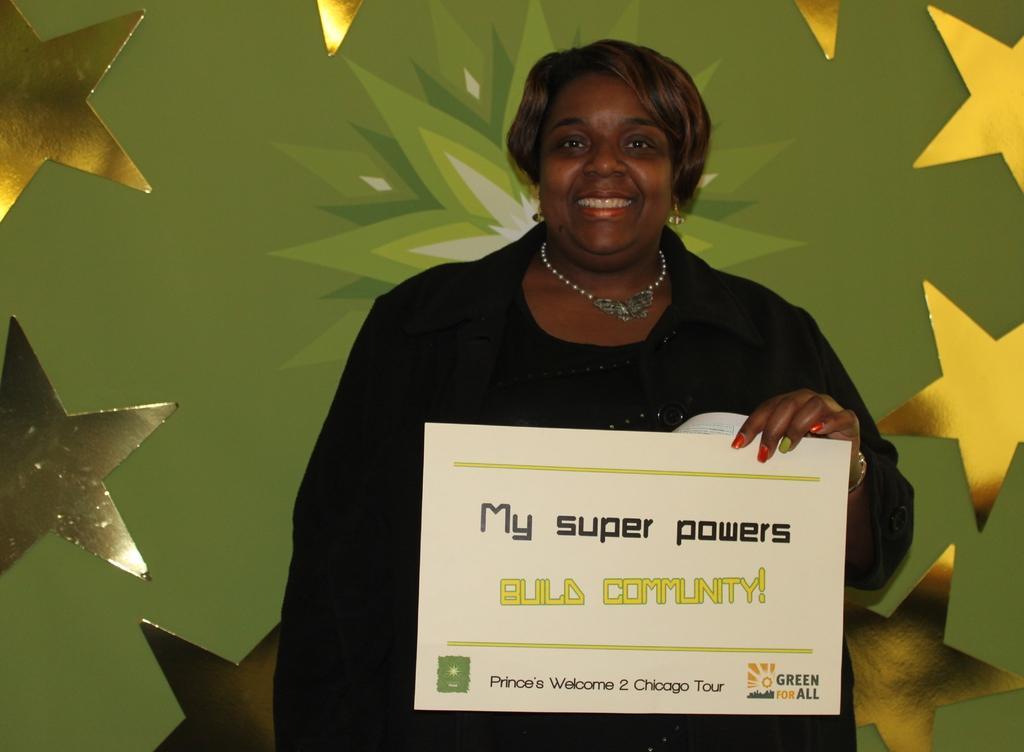Please provide a concise description of this image. A woman is holding a card in her hand, she wore a black color dress and there are star shaped things around her. 